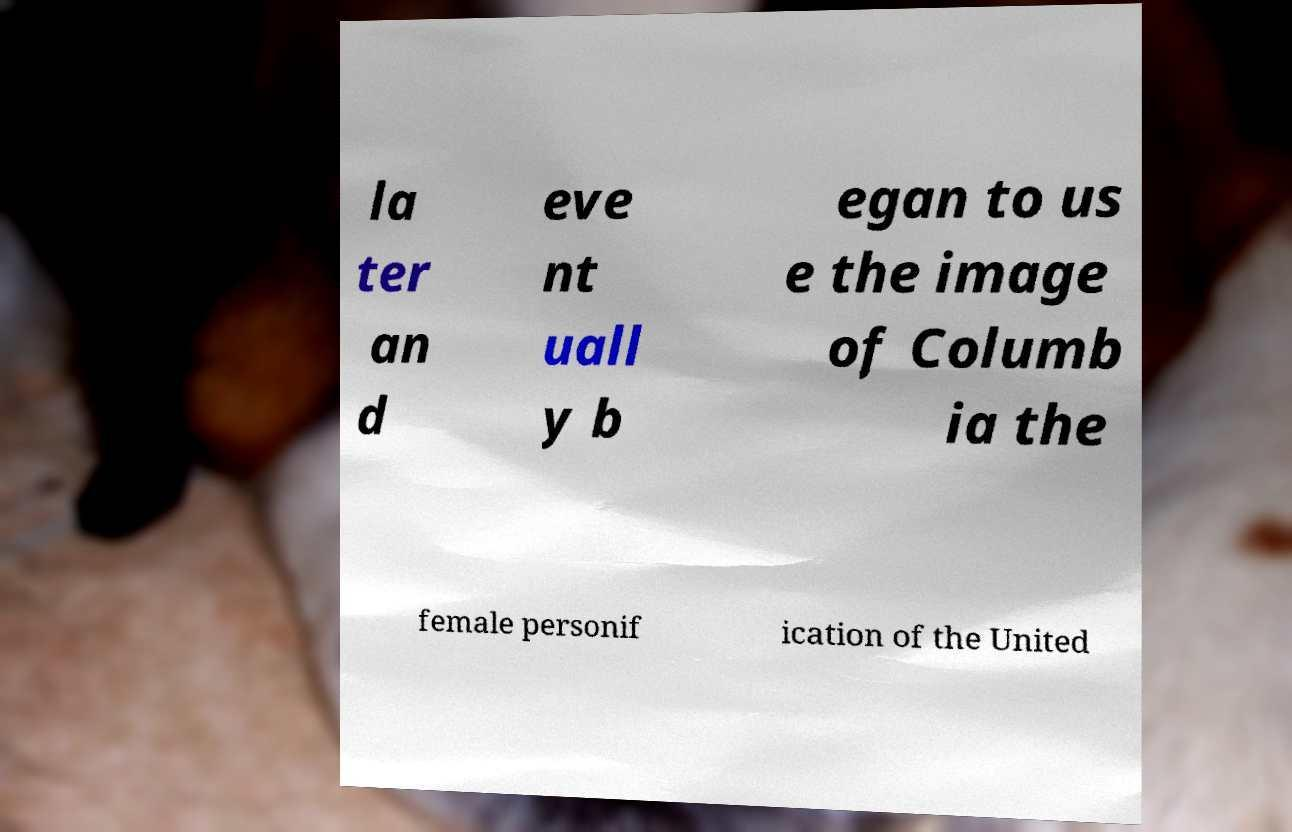What messages or text are displayed in this image? I need them in a readable, typed format. la ter an d eve nt uall y b egan to us e the image of Columb ia the female personif ication of the United 